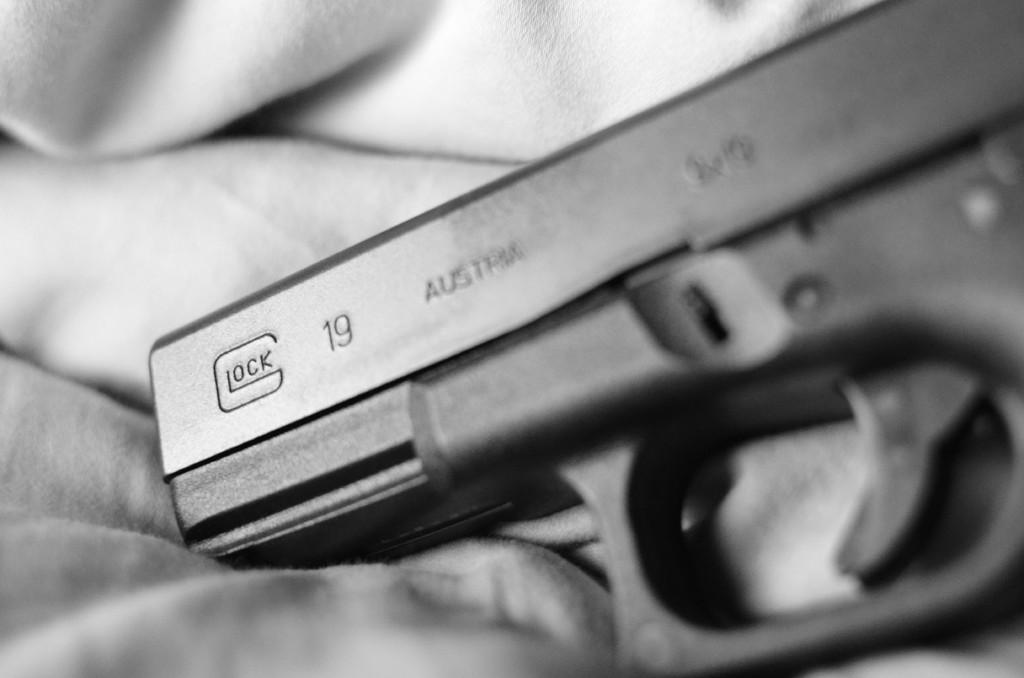What is the main object in the center of the image? There is a pistol in the center of the image. How many planes are flying in the background of the image? There is no background or planes mentioned in the image; it only features a pistol in the center. What type of system is being used to operate the pistol in the image? The image does not provide any information about a system or how the pistol is being operated. 